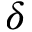Convert formula to latex. <formula><loc_0><loc_0><loc_500><loc_500>\delta</formula> 